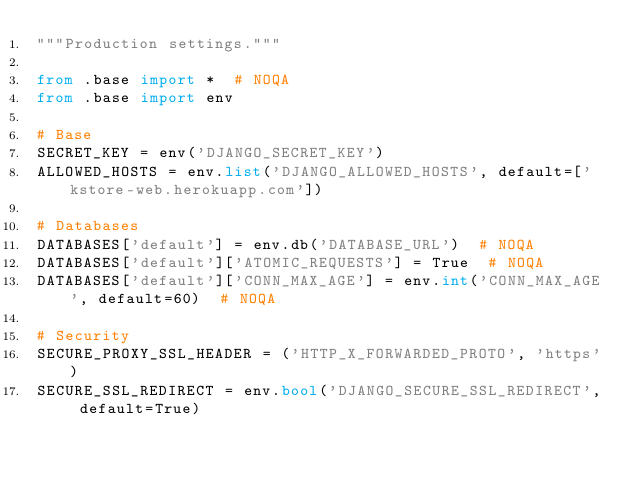<code> <loc_0><loc_0><loc_500><loc_500><_Python_>"""Production settings."""

from .base import *  # NOQA
from .base import env

# Base
SECRET_KEY = env('DJANGO_SECRET_KEY')
ALLOWED_HOSTS = env.list('DJANGO_ALLOWED_HOSTS', default=['kstore-web.herokuapp.com'])

# Databases
DATABASES['default'] = env.db('DATABASE_URL')  # NOQA
DATABASES['default']['ATOMIC_REQUESTS'] = True  # NOQA
DATABASES['default']['CONN_MAX_AGE'] = env.int('CONN_MAX_AGE', default=60)  # NOQA

# Security
SECURE_PROXY_SSL_HEADER = ('HTTP_X_FORWARDED_PROTO', 'https')
SECURE_SSL_REDIRECT = env.bool('DJANGO_SECURE_SSL_REDIRECT', default=True)</code> 